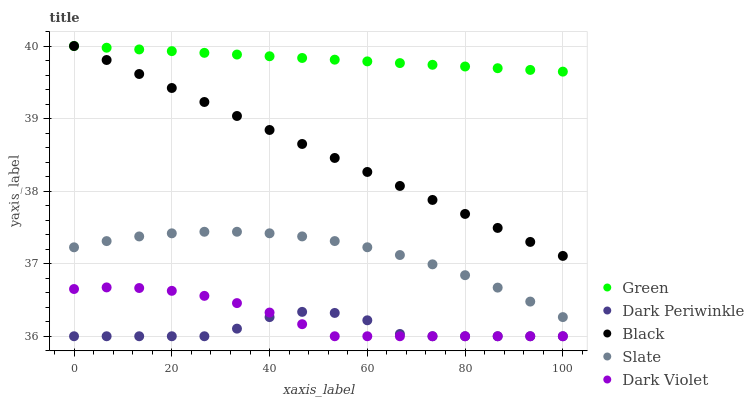Does Dark Periwinkle have the minimum area under the curve?
Answer yes or no. Yes. Does Green have the maximum area under the curve?
Answer yes or no. Yes. Does Slate have the minimum area under the curve?
Answer yes or no. No. Does Slate have the maximum area under the curve?
Answer yes or no. No. Is Green the smoothest?
Answer yes or no. Yes. Is Dark Periwinkle the roughest?
Answer yes or no. Yes. Is Slate the smoothest?
Answer yes or no. No. Is Slate the roughest?
Answer yes or no. No. Does Dark Periwinkle have the lowest value?
Answer yes or no. Yes. Does Slate have the lowest value?
Answer yes or no. No. Does Green have the highest value?
Answer yes or no. Yes. Does Slate have the highest value?
Answer yes or no. No. Is Dark Violet less than Green?
Answer yes or no. Yes. Is Slate greater than Dark Violet?
Answer yes or no. Yes. Does Dark Violet intersect Dark Periwinkle?
Answer yes or no. Yes. Is Dark Violet less than Dark Periwinkle?
Answer yes or no. No. Is Dark Violet greater than Dark Periwinkle?
Answer yes or no. No. Does Dark Violet intersect Green?
Answer yes or no. No. 